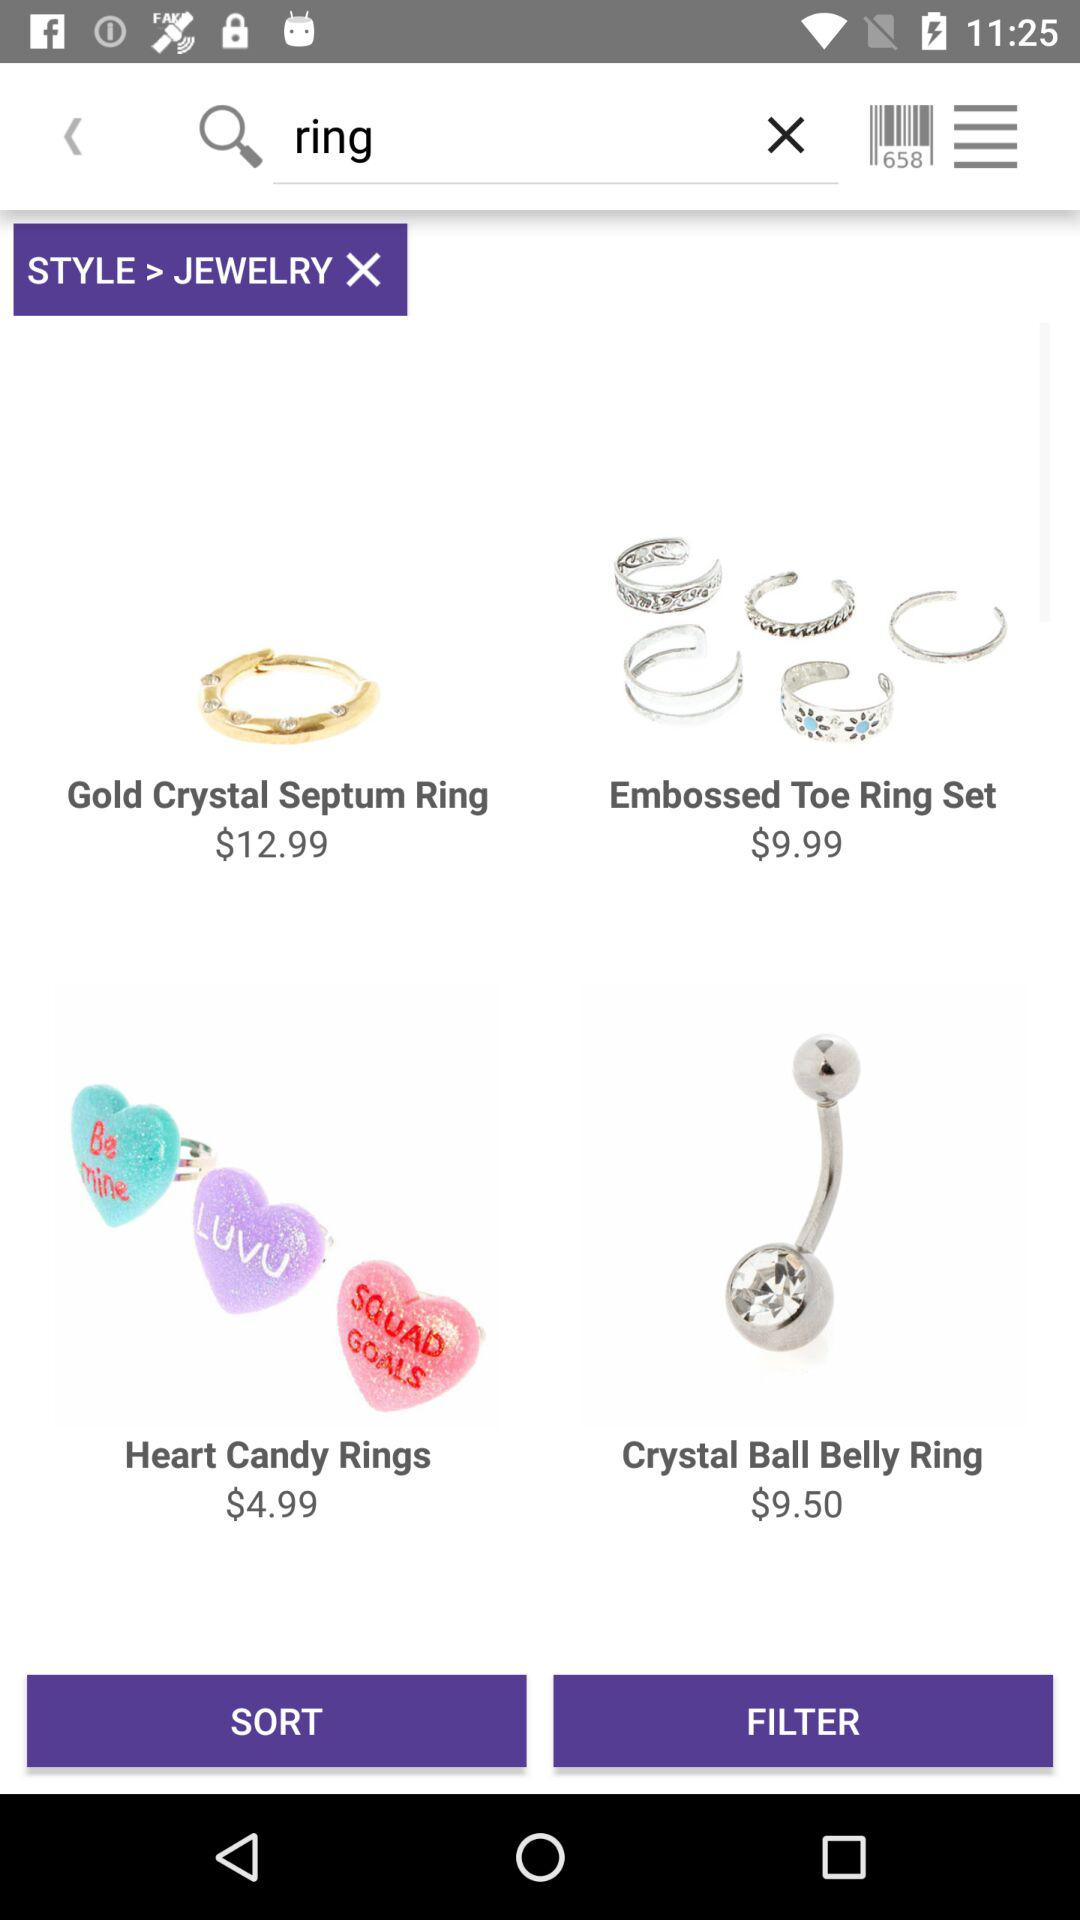Which option is selected in the "STYLE"? The selected option is "JEWELRY". 